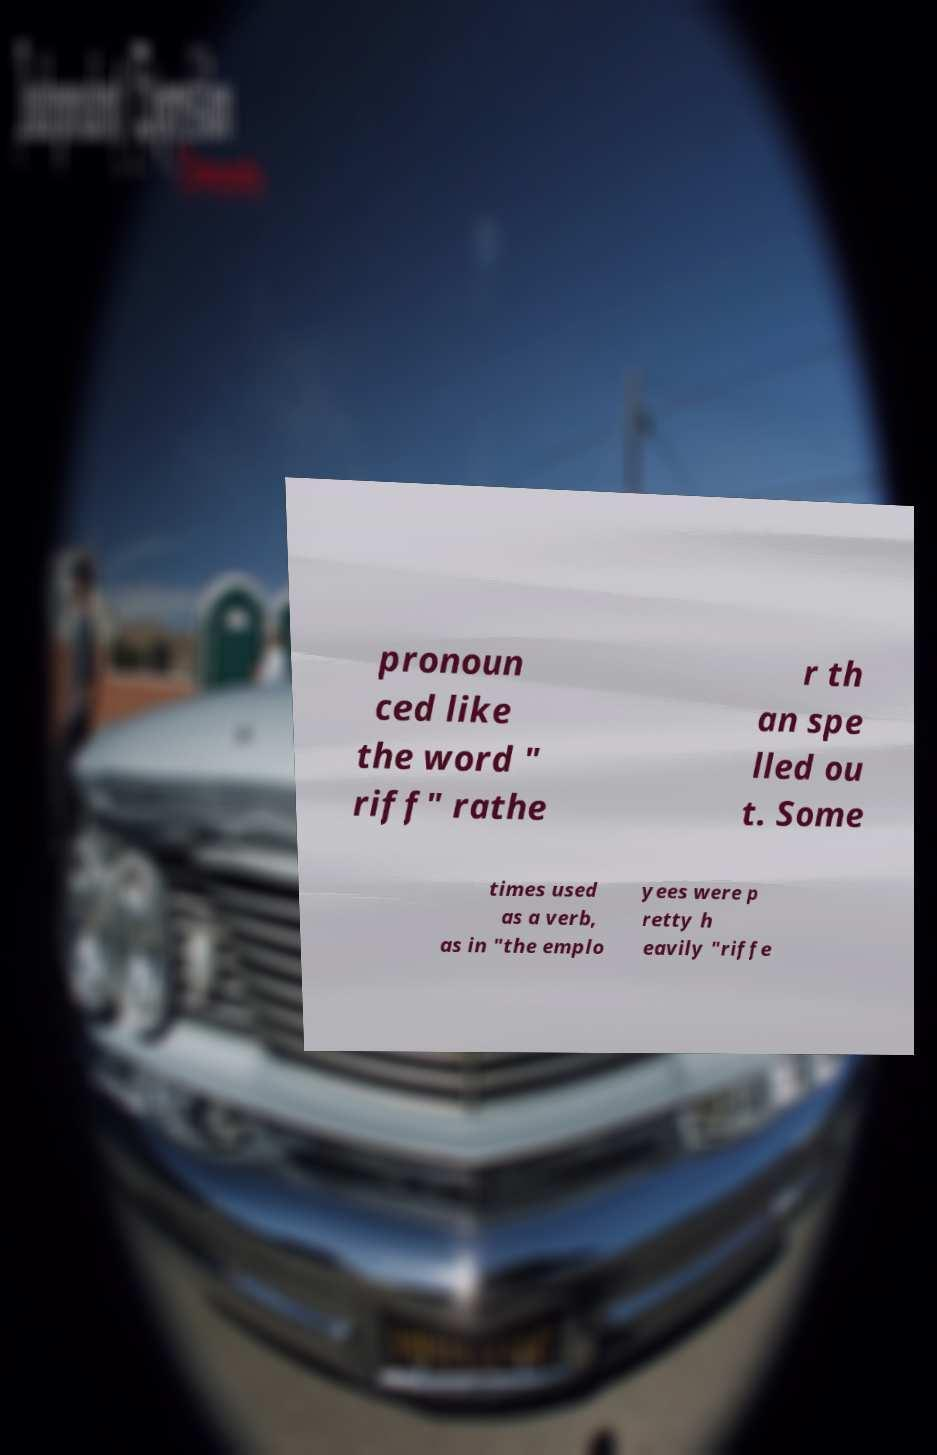For documentation purposes, I need the text within this image transcribed. Could you provide that? pronoun ced like the word " riff" rathe r th an spe lled ou t. Some times used as a verb, as in "the emplo yees were p retty h eavily "riffe 